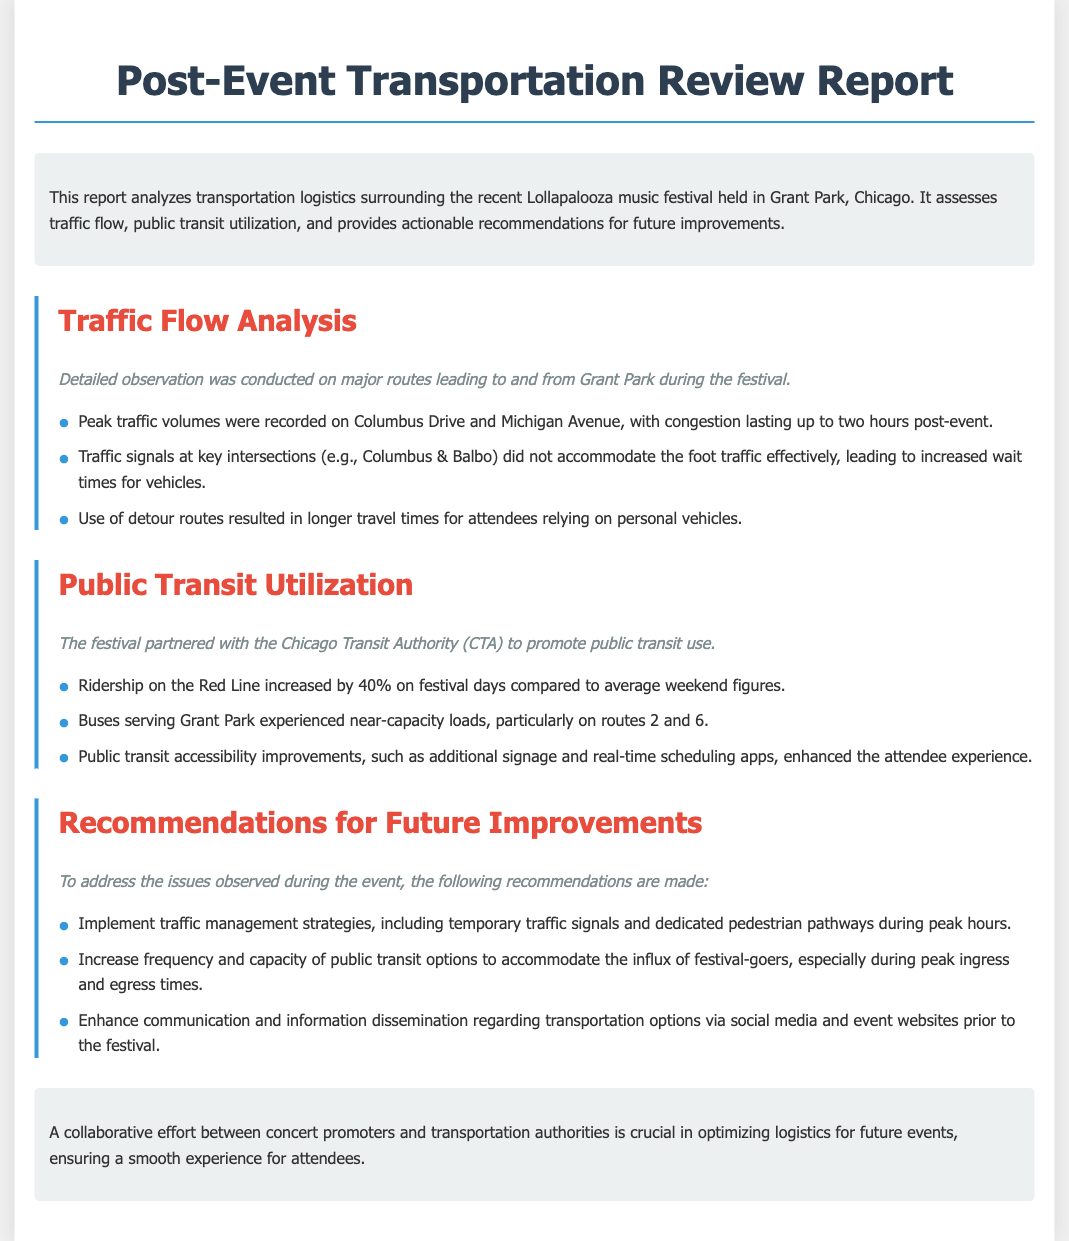What festival is analyzed in the report? The report studies the transportation logistics surrounding the recent Lollapalooza music festival, as mentioned in the introduction.
Answer: Lollapalooza What was the peak traffic duration post-event? The report states that congestion lasted up to two hours post-event on key routes.
Answer: two hours By what percentage did Red Line ridership increase? It is mentioned in the document that ridership on the Red Line increased by 40% on festival days compared to average weekend figures.
Answer: 40% What traffic signal location is specifically highlighted in the report? The document mentions Columbus & Balbo as a key intersection where traffic signals did not effectively accommodate foot traffic.
Answer: Columbus & Balbo What recommendation is given regarding public transit capacity? The report suggests increasing the frequency and capacity of public transit options to accommodate festival-goers.
Answer: Increase frequency and capacity How did the report describe public transit accessibility improvements? The summary notes that enhancements such as additional signage and real-time scheduling apps improved the attendee experience.
Answer: improved the attendee experience What color is used for the section headers? The document specifies that the color used for the section headers is a shade of red, specifically noted in the CSS styling.
Answer: red What is highlighted as crucial for optimizing logistics for future events? The conclusion emphasizes the importance of a collaborative effort between concert promoters and transportation authorities.
Answer: collaborative effort 